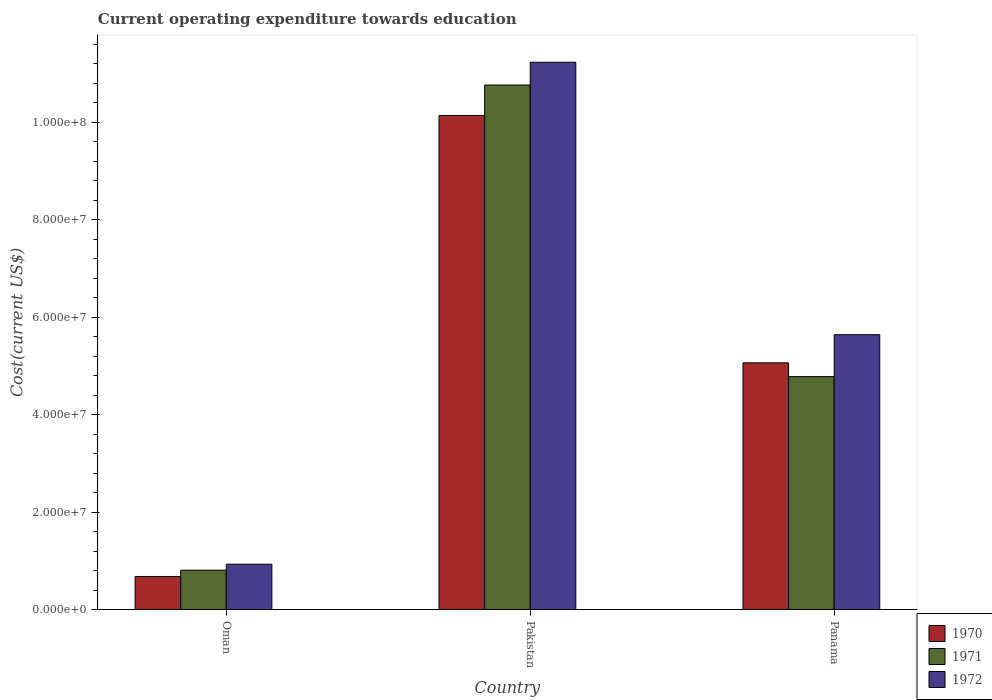Are the number of bars per tick equal to the number of legend labels?
Offer a very short reply. Yes. How many bars are there on the 1st tick from the right?
Offer a very short reply. 3. In how many cases, is the number of bars for a given country not equal to the number of legend labels?
Your response must be concise. 0. What is the expenditure towards education in 1972 in Pakistan?
Your answer should be very brief. 1.12e+08. Across all countries, what is the maximum expenditure towards education in 1972?
Ensure brevity in your answer.  1.12e+08. Across all countries, what is the minimum expenditure towards education in 1970?
Your answer should be compact. 6.80e+06. In which country was the expenditure towards education in 1971 minimum?
Provide a succinct answer. Oman. What is the total expenditure towards education in 1971 in the graph?
Give a very brief answer. 1.64e+08. What is the difference between the expenditure towards education in 1970 in Oman and that in Pakistan?
Give a very brief answer. -9.46e+07. What is the difference between the expenditure towards education in 1972 in Oman and the expenditure towards education in 1970 in Pakistan?
Ensure brevity in your answer.  -9.21e+07. What is the average expenditure towards education in 1971 per country?
Your answer should be very brief. 5.45e+07. What is the difference between the expenditure towards education of/in 1972 and expenditure towards education of/in 1971 in Pakistan?
Provide a short and direct response. 4.68e+06. What is the ratio of the expenditure towards education in 1971 in Oman to that in Pakistan?
Your response must be concise. 0.08. What is the difference between the highest and the second highest expenditure towards education in 1972?
Keep it short and to the point. 4.71e+07. What is the difference between the highest and the lowest expenditure towards education in 1971?
Ensure brevity in your answer.  9.96e+07. What does the 1st bar from the right in Pakistan represents?
Keep it short and to the point. 1972. How many countries are there in the graph?
Offer a terse response. 3. What is the difference between two consecutive major ticks on the Y-axis?
Give a very brief answer. 2.00e+07. Does the graph contain any zero values?
Your answer should be very brief. No. What is the title of the graph?
Offer a terse response. Current operating expenditure towards education. What is the label or title of the Y-axis?
Your answer should be compact. Cost(current US$). What is the Cost(current US$) of 1970 in Oman?
Give a very brief answer. 6.80e+06. What is the Cost(current US$) in 1971 in Oman?
Ensure brevity in your answer.  8.09e+06. What is the Cost(current US$) in 1972 in Oman?
Your answer should be very brief. 9.32e+06. What is the Cost(current US$) in 1970 in Pakistan?
Your response must be concise. 1.01e+08. What is the Cost(current US$) in 1971 in Pakistan?
Offer a terse response. 1.08e+08. What is the Cost(current US$) in 1972 in Pakistan?
Ensure brevity in your answer.  1.12e+08. What is the Cost(current US$) of 1970 in Panama?
Give a very brief answer. 5.07e+07. What is the Cost(current US$) in 1971 in Panama?
Make the answer very short. 4.78e+07. What is the Cost(current US$) of 1972 in Panama?
Offer a very short reply. 5.64e+07. Across all countries, what is the maximum Cost(current US$) of 1970?
Offer a terse response. 1.01e+08. Across all countries, what is the maximum Cost(current US$) in 1971?
Your answer should be very brief. 1.08e+08. Across all countries, what is the maximum Cost(current US$) of 1972?
Offer a very short reply. 1.12e+08. Across all countries, what is the minimum Cost(current US$) in 1970?
Offer a terse response. 6.80e+06. Across all countries, what is the minimum Cost(current US$) in 1971?
Ensure brevity in your answer.  8.09e+06. Across all countries, what is the minimum Cost(current US$) in 1972?
Give a very brief answer. 9.32e+06. What is the total Cost(current US$) in 1970 in the graph?
Make the answer very short. 1.59e+08. What is the total Cost(current US$) in 1971 in the graph?
Provide a short and direct response. 1.64e+08. What is the total Cost(current US$) of 1972 in the graph?
Your response must be concise. 1.78e+08. What is the difference between the Cost(current US$) in 1970 in Oman and that in Pakistan?
Provide a succinct answer. -9.46e+07. What is the difference between the Cost(current US$) in 1971 in Oman and that in Pakistan?
Your answer should be very brief. -9.96e+07. What is the difference between the Cost(current US$) in 1972 in Oman and that in Pakistan?
Keep it short and to the point. -1.03e+08. What is the difference between the Cost(current US$) in 1970 in Oman and that in Panama?
Keep it short and to the point. -4.38e+07. What is the difference between the Cost(current US$) in 1971 in Oman and that in Panama?
Provide a succinct answer. -3.97e+07. What is the difference between the Cost(current US$) in 1972 in Oman and that in Panama?
Ensure brevity in your answer.  -4.71e+07. What is the difference between the Cost(current US$) in 1970 in Pakistan and that in Panama?
Your response must be concise. 5.08e+07. What is the difference between the Cost(current US$) of 1971 in Pakistan and that in Panama?
Provide a succinct answer. 5.98e+07. What is the difference between the Cost(current US$) in 1972 in Pakistan and that in Panama?
Provide a succinct answer. 5.59e+07. What is the difference between the Cost(current US$) in 1970 in Oman and the Cost(current US$) in 1971 in Pakistan?
Offer a terse response. -1.01e+08. What is the difference between the Cost(current US$) of 1970 in Oman and the Cost(current US$) of 1972 in Pakistan?
Provide a short and direct response. -1.06e+08. What is the difference between the Cost(current US$) in 1971 in Oman and the Cost(current US$) in 1972 in Pakistan?
Make the answer very short. -1.04e+08. What is the difference between the Cost(current US$) in 1970 in Oman and the Cost(current US$) in 1971 in Panama?
Make the answer very short. -4.10e+07. What is the difference between the Cost(current US$) of 1970 in Oman and the Cost(current US$) of 1972 in Panama?
Your response must be concise. -4.96e+07. What is the difference between the Cost(current US$) of 1971 in Oman and the Cost(current US$) of 1972 in Panama?
Ensure brevity in your answer.  -4.83e+07. What is the difference between the Cost(current US$) in 1970 in Pakistan and the Cost(current US$) in 1971 in Panama?
Give a very brief answer. 5.36e+07. What is the difference between the Cost(current US$) of 1970 in Pakistan and the Cost(current US$) of 1972 in Panama?
Make the answer very short. 4.50e+07. What is the difference between the Cost(current US$) of 1971 in Pakistan and the Cost(current US$) of 1972 in Panama?
Your answer should be compact. 5.12e+07. What is the average Cost(current US$) of 1970 per country?
Give a very brief answer. 5.30e+07. What is the average Cost(current US$) in 1971 per country?
Keep it short and to the point. 5.45e+07. What is the average Cost(current US$) of 1972 per country?
Offer a terse response. 5.94e+07. What is the difference between the Cost(current US$) in 1970 and Cost(current US$) in 1971 in Oman?
Ensure brevity in your answer.  -1.29e+06. What is the difference between the Cost(current US$) of 1970 and Cost(current US$) of 1972 in Oman?
Give a very brief answer. -2.52e+06. What is the difference between the Cost(current US$) in 1971 and Cost(current US$) in 1972 in Oman?
Make the answer very short. -1.23e+06. What is the difference between the Cost(current US$) of 1970 and Cost(current US$) of 1971 in Pakistan?
Your answer should be very brief. -6.25e+06. What is the difference between the Cost(current US$) of 1970 and Cost(current US$) of 1972 in Pakistan?
Keep it short and to the point. -1.09e+07. What is the difference between the Cost(current US$) in 1971 and Cost(current US$) in 1972 in Pakistan?
Your answer should be very brief. -4.68e+06. What is the difference between the Cost(current US$) in 1970 and Cost(current US$) in 1971 in Panama?
Make the answer very short. 2.83e+06. What is the difference between the Cost(current US$) of 1970 and Cost(current US$) of 1972 in Panama?
Provide a succinct answer. -5.77e+06. What is the difference between the Cost(current US$) of 1971 and Cost(current US$) of 1972 in Panama?
Your answer should be very brief. -8.60e+06. What is the ratio of the Cost(current US$) of 1970 in Oman to that in Pakistan?
Make the answer very short. 0.07. What is the ratio of the Cost(current US$) in 1971 in Oman to that in Pakistan?
Give a very brief answer. 0.08. What is the ratio of the Cost(current US$) in 1972 in Oman to that in Pakistan?
Your response must be concise. 0.08. What is the ratio of the Cost(current US$) of 1970 in Oman to that in Panama?
Keep it short and to the point. 0.13. What is the ratio of the Cost(current US$) of 1971 in Oman to that in Panama?
Offer a terse response. 0.17. What is the ratio of the Cost(current US$) of 1972 in Oman to that in Panama?
Your answer should be very brief. 0.17. What is the ratio of the Cost(current US$) of 1970 in Pakistan to that in Panama?
Your response must be concise. 2. What is the ratio of the Cost(current US$) in 1971 in Pakistan to that in Panama?
Your answer should be compact. 2.25. What is the ratio of the Cost(current US$) of 1972 in Pakistan to that in Panama?
Give a very brief answer. 1.99. What is the difference between the highest and the second highest Cost(current US$) of 1970?
Your answer should be compact. 5.08e+07. What is the difference between the highest and the second highest Cost(current US$) in 1971?
Your answer should be very brief. 5.98e+07. What is the difference between the highest and the second highest Cost(current US$) in 1972?
Ensure brevity in your answer.  5.59e+07. What is the difference between the highest and the lowest Cost(current US$) of 1970?
Offer a terse response. 9.46e+07. What is the difference between the highest and the lowest Cost(current US$) in 1971?
Offer a terse response. 9.96e+07. What is the difference between the highest and the lowest Cost(current US$) of 1972?
Offer a terse response. 1.03e+08. 